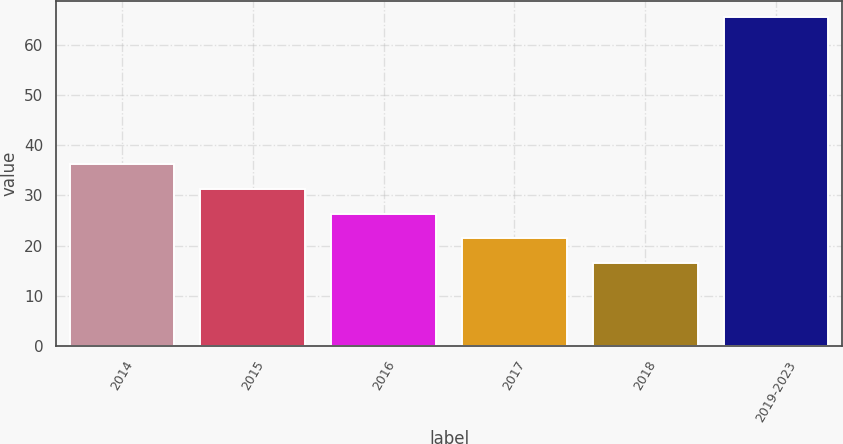Convert chart. <chart><loc_0><loc_0><loc_500><loc_500><bar_chart><fcel>2014<fcel>2015<fcel>2016<fcel>2017<fcel>2018<fcel>2019-2023<nl><fcel>36.2<fcel>31.3<fcel>26.4<fcel>21.5<fcel>16.6<fcel>65.6<nl></chart> 